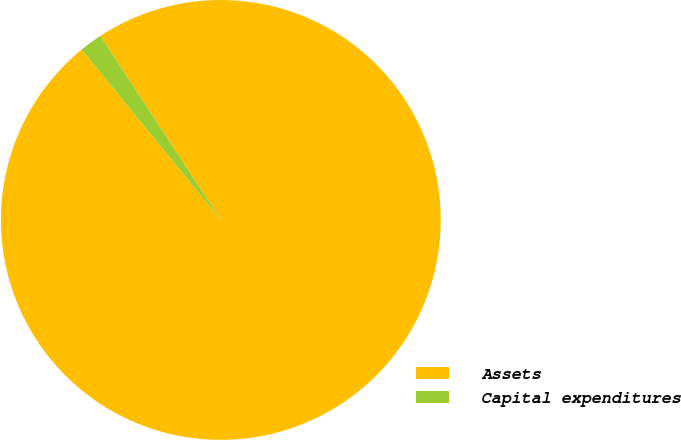<chart> <loc_0><loc_0><loc_500><loc_500><pie_chart><fcel>Assets<fcel>Capital expenditures<nl><fcel>98.32%<fcel>1.68%<nl></chart> 